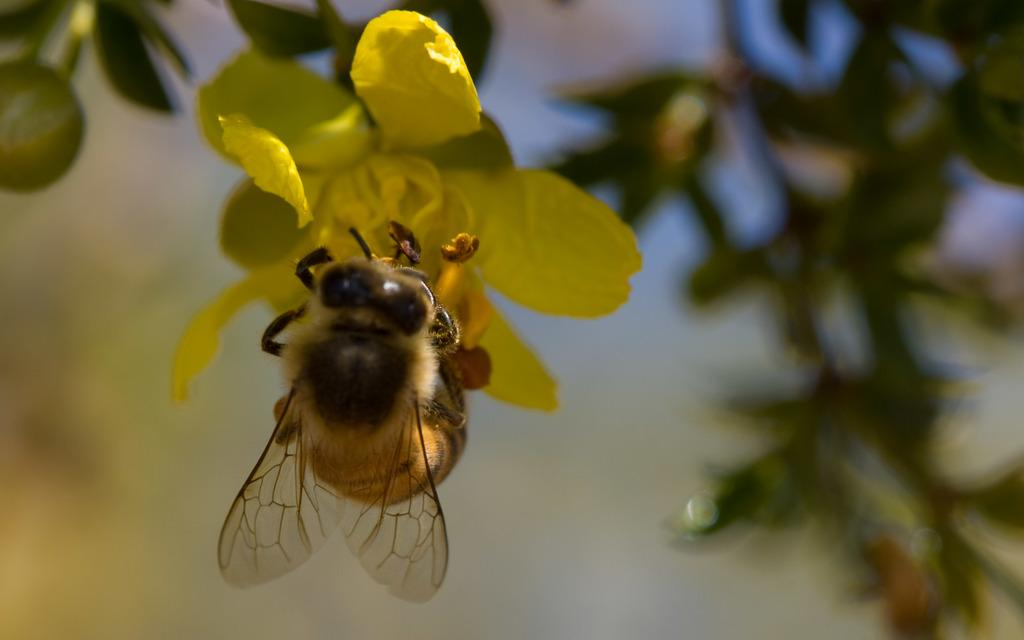What type of insect is in the image? There is a honey bee in the image. What is the honey bee doing in the image? The honey bee is on a yellow flower. Can you describe the background of the image? The background of the image is blurred. What type of net is being used to catch the honey bee in the image? There is no net present in the image, and the honey bee is not being caught. 